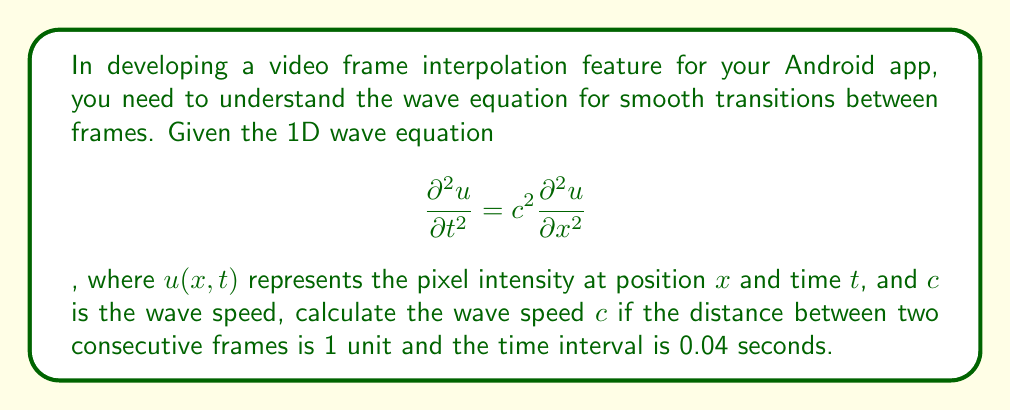Show me your answer to this math problem. To solve this problem, we'll follow these steps:

1) In the context of video frame interpolation, we can interpret the wave equation as describing how pixel intensities change over time and space between frames.

2) The wave speed $c$ represents how fast the pixel intensity changes propagate between frames.

3) We're given two pieces of information:
   - The distance between frames is 1 unit (Δx = 1)
   - The time interval between frames is 0.04 seconds (Δt = 0.04)

4) The general formula for wave speed is:
   
   $$c = \frac{\text{distance}}{\text{time}} = \frac{\Delta x}{\Delta t}$$

5) Substituting our known values:

   $$c = \frac{1}{0.04}$$

6) Calculating:

   $$c = 25 \text{ units/second}$$

This means the wave (or change in pixel intensity) travels 25 units per second between frames.
Answer: $c = 25 \text{ units/second}$ 